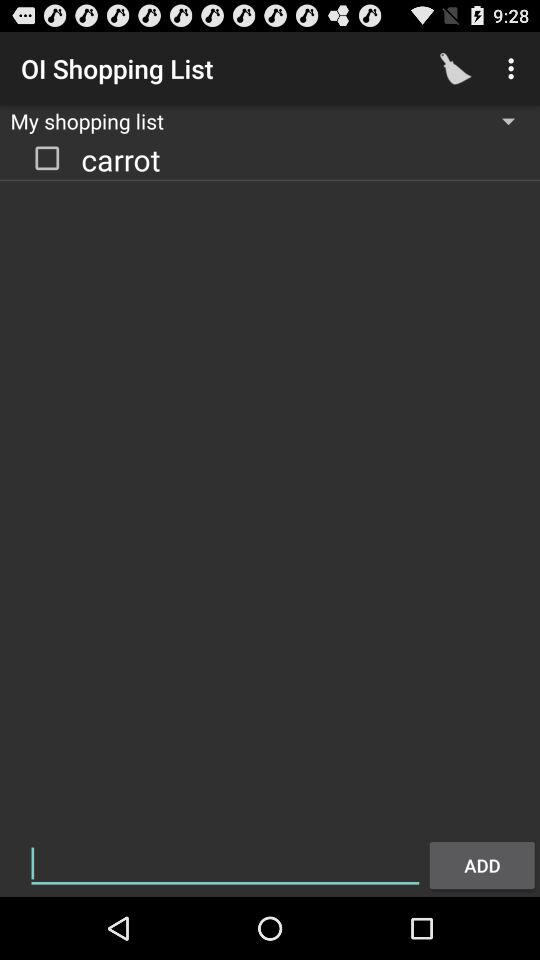Is the item in the list checked or unchecked? The item in the list is unchecked. 